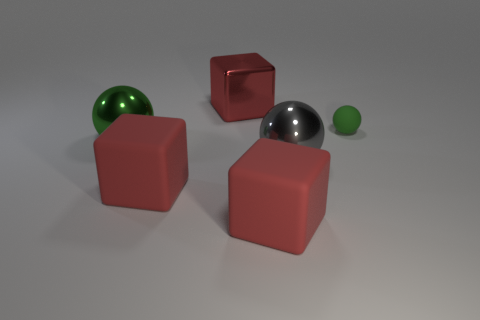How many red blocks must be subtracted to get 1 red blocks? 2 Subtract all green balls. How many balls are left? 1 Add 3 green rubber spheres. How many objects exist? 9 Subtract all green spheres. How many spheres are left? 1 Subtract 1 spheres. How many spheres are left? 2 Subtract all tiny brown shiny cubes. Subtract all big things. How many objects are left? 1 Add 4 big gray spheres. How many big gray spheres are left? 5 Add 3 large brown cubes. How many large brown cubes exist? 3 Subtract 0 blue cylinders. How many objects are left? 6 Subtract all brown cubes. Subtract all yellow cylinders. How many cubes are left? 3 